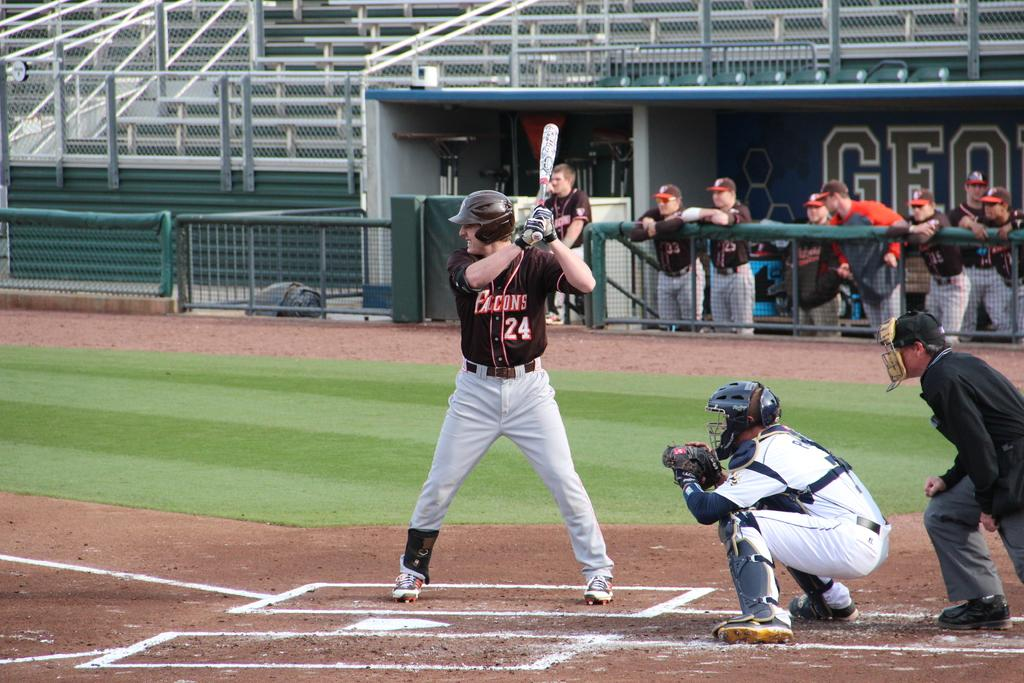Provide a one-sentence caption for the provided image. a baseball player up to bat wears a Falcons 24 jersey. 